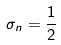<formula> <loc_0><loc_0><loc_500><loc_500>\sigma _ { n } = \frac { 1 } { 2 }</formula> 